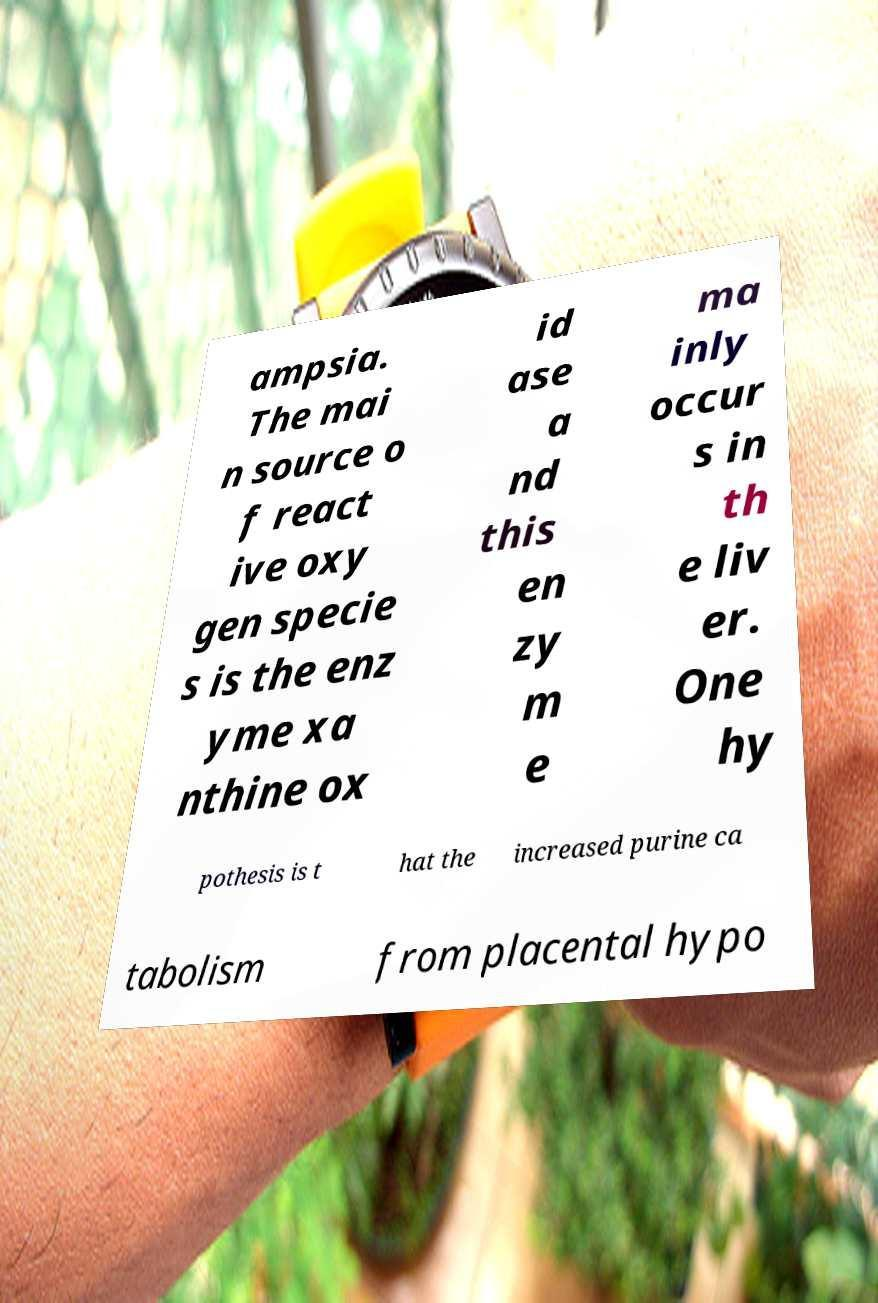Could you extract and type out the text from this image? ampsia. The mai n source o f react ive oxy gen specie s is the enz yme xa nthine ox id ase a nd this en zy m e ma inly occur s in th e liv er. One hy pothesis is t hat the increased purine ca tabolism from placental hypo 